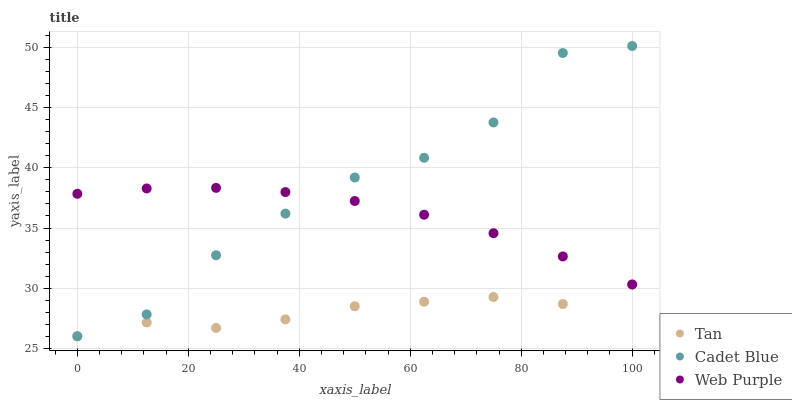Does Tan have the minimum area under the curve?
Answer yes or no. Yes. Does Cadet Blue have the maximum area under the curve?
Answer yes or no. Yes. Does Web Purple have the minimum area under the curve?
Answer yes or no. No. Does Web Purple have the maximum area under the curve?
Answer yes or no. No. Is Web Purple the smoothest?
Answer yes or no. Yes. Is Cadet Blue the roughest?
Answer yes or no. Yes. Is Cadet Blue the smoothest?
Answer yes or no. No. Is Web Purple the roughest?
Answer yes or no. No. Does Tan have the lowest value?
Answer yes or no. Yes. Does Web Purple have the lowest value?
Answer yes or no. No. Does Cadet Blue have the highest value?
Answer yes or no. Yes. Does Web Purple have the highest value?
Answer yes or no. No. Is Tan less than Web Purple?
Answer yes or no. Yes. Is Web Purple greater than Tan?
Answer yes or no. Yes. Does Tan intersect Cadet Blue?
Answer yes or no. Yes. Is Tan less than Cadet Blue?
Answer yes or no. No. Is Tan greater than Cadet Blue?
Answer yes or no. No. Does Tan intersect Web Purple?
Answer yes or no. No. 